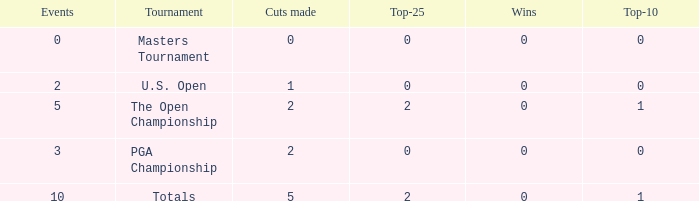Would you mind parsing the complete table? {'header': ['Events', 'Tournament', 'Cuts made', 'Top-25', 'Wins', 'Top-10'], 'rows': [['0', 'Masters Tournament', '0', '0', '0', '0'], ['2', 'U.S. Open', '1', '0', '0', '0'], ['5', 'The Open Championship', '2', '2', '0', '1'], ['3', 'PGA Championship', '2', '0', '0', '0'], ['10', 'Totals', '5', '2', '0', '1']]} What is the total number of top-25s for events with 0 wins? 0.0. 